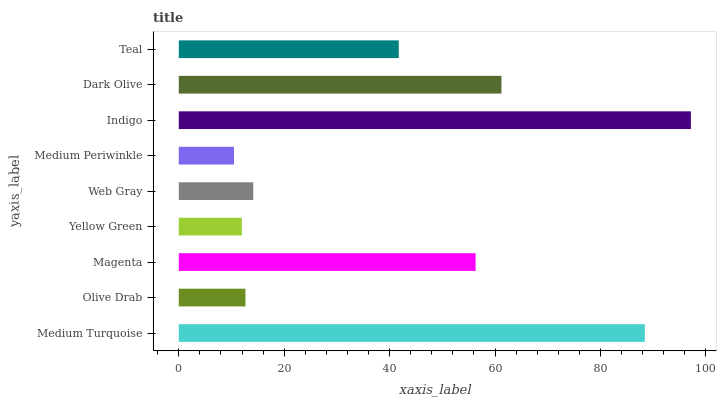Is Medium Periwinkle the minimum?
Answer yes or no. Yes. Is Indigo the maximum?
Answer yes or no. Yes. Is Olive Drab the minimum?
Answer yes or no. No. Is Olive Drab the maximum?
Answer yes or no. No. Is Medium Turquoise greater than Olive Drab?
Answer yes or no. Yes. Is Olive Drab less than Medium Turquoise?
Answer yes or no. Yes. Is Olive Drab greater than Medium Turquoise?
Answer yes or no. No. Is Medium Turquoise less than Olive Drab?
Answer yes or no. No. Is Teal the high median?
Answer yes or no. Yes. Is Teal the low median?
Answer yes or no. Yes. Is Magenta the high median?
Answer yes or no. No. Is Medium Periwinkle the low median?
Answer yes or no. No. 